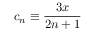Convert formula to latex. <formula><loc_0><loc_0><loc_500><loc_500>c _ { n } \equiv \frac { 3 x } { 2 n + 1 }</formula> 